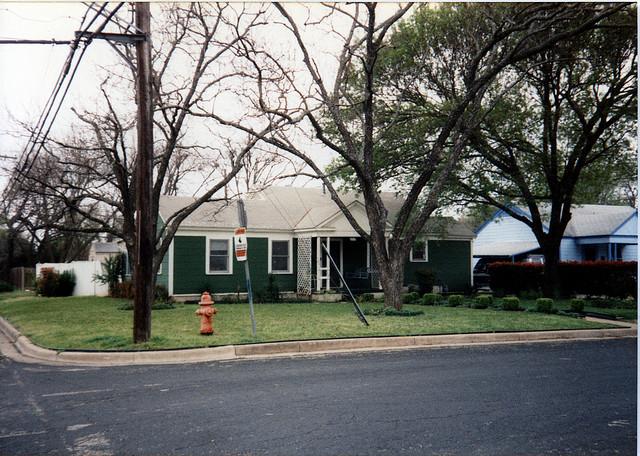What color is the fire hydrant?
Short answer required. Red. How many cars are in the driveway?
Concise answer only. 0. Are there any cars on the street?
Write a very short answer. No. How many bushes are along the walkway?
Short answer required. 10. Is this BMW?
Quick response, please. No. 